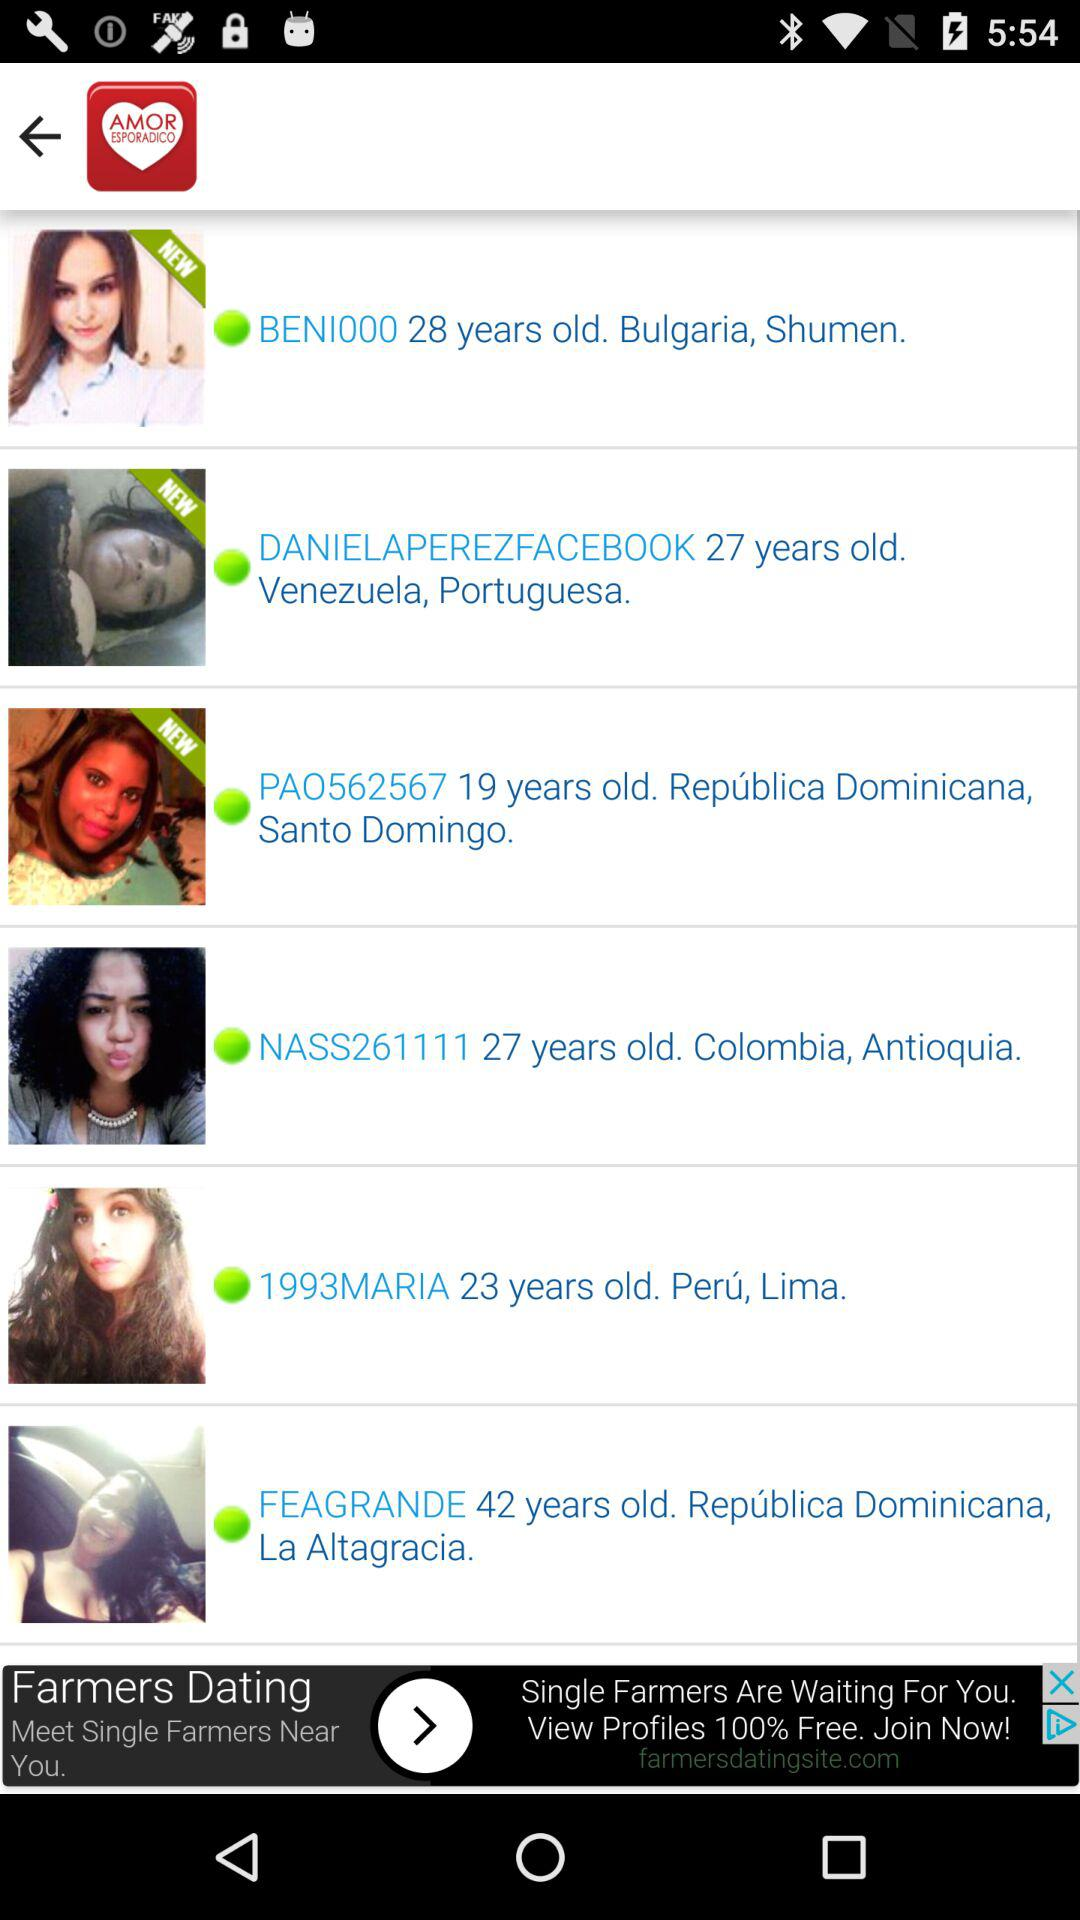What is the age of "BENI000"? "BENI000" is 28 years old. 